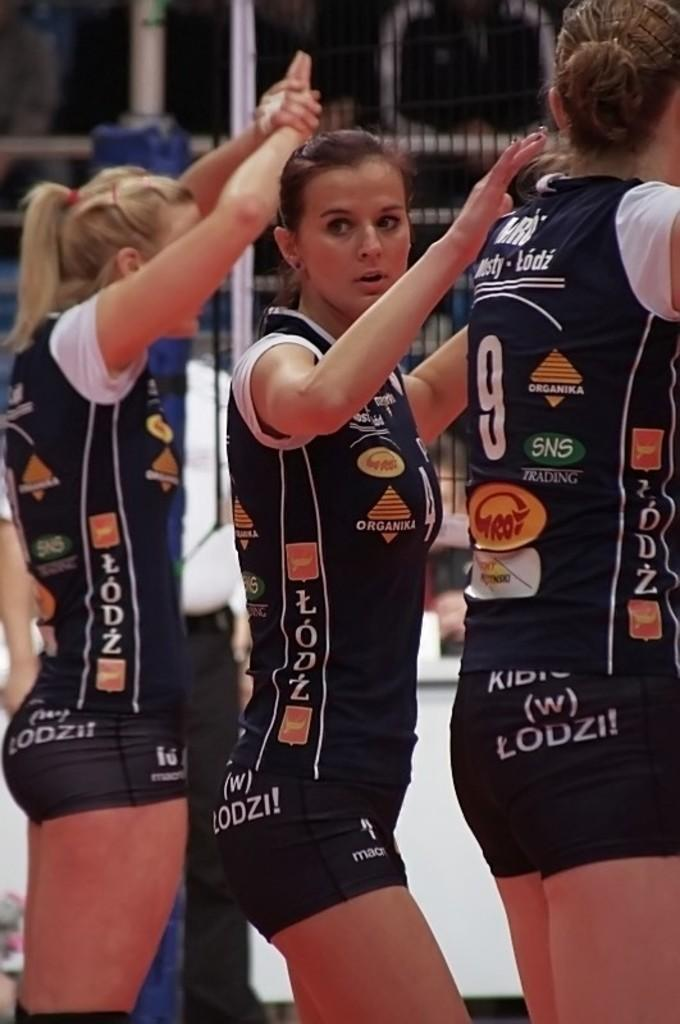<image>
Describe the image concisely. A girl is wearing a uniform with the number 9 on it. 